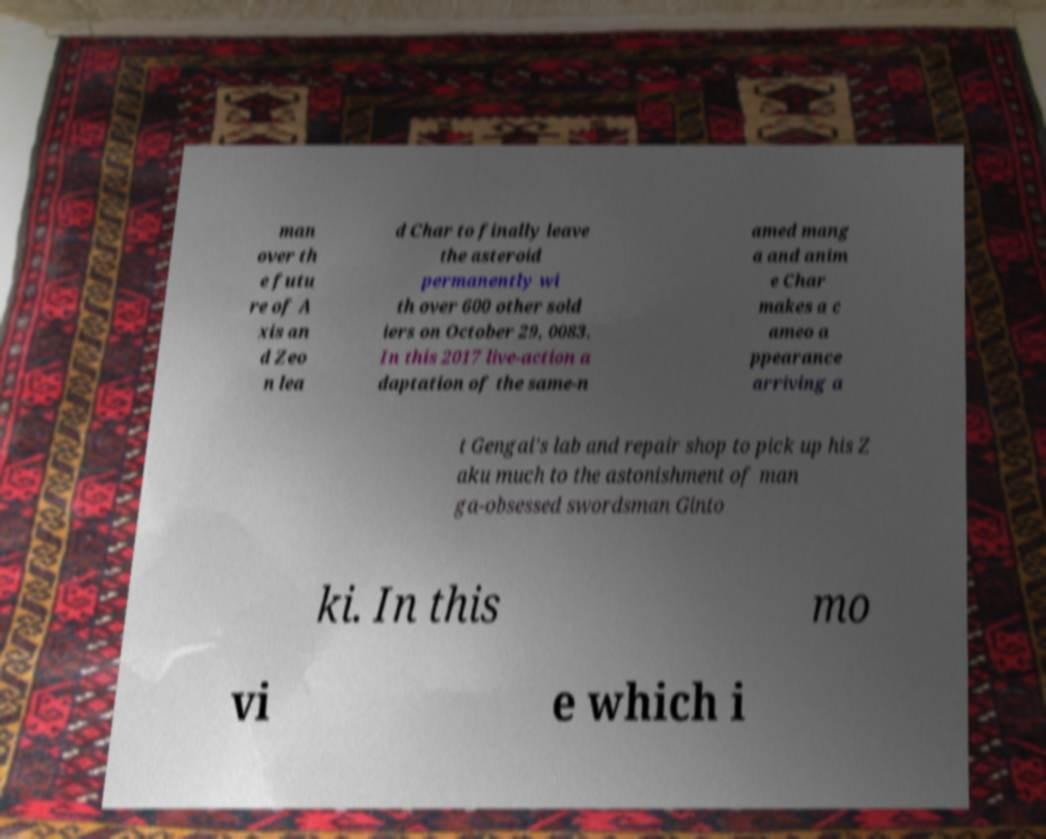What messages or text are displayed in this image? I need them in a readable, typed format. man over th e futu re of A xis an d Zeo n lea d Char to finally leave the asteroid permanently wi th over 600 other sold iers on October 29, 0083. In this 2017 live-action a daptation of the same-n amed mang a and anim e Char makes a c ameo a ppearance arriving a t Gengai's lab and repair shop to pick up his Z aku much to the astonishment of man ga-obsessed swordsman Ginto ki. In this mo vi e which i 